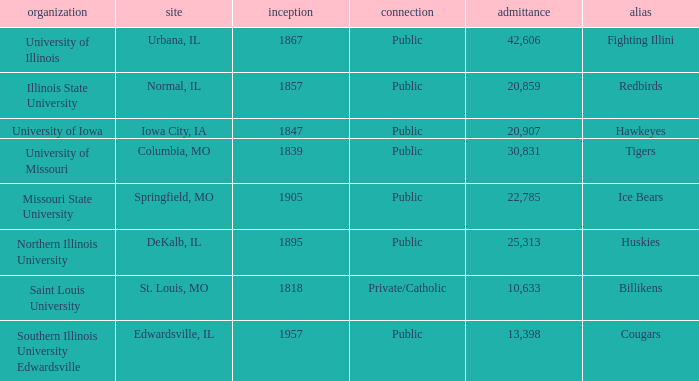Which institution is private/catholic? Saint Louis University. 